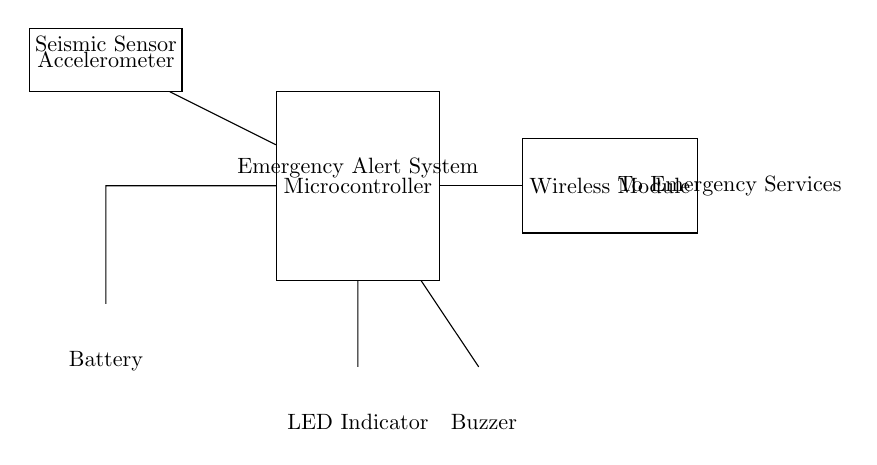What component detects seismic activity? The component that detects seismic activity in the circuit is the accelerometer. It is shown in the diagram labeled as "Seismic Sensor."
Answer: Accelerometer What is the function of the wireless module? The wireless module's function is to send alerts to emergency services. This is indicated by the label "To Emergency Services" next to the wireless module in the diagram.
Answer: Send alerts What are the two output indicators for the emergency alert system? The two output indicators are the LED Indicator and the Buzzer. These components are shown at the bottom of the circuit and are labeled accordingly.
Answer: LED Indicator and Buzzer How is the microcontroller powered? The microcontroller is powered by a battery. The circuit shows a connection from the battery, which is labeled as such, leading to the microcontroller.
Answer: Battery What is the role of the microcontroller in this circuit? The microcontroller's role in this circuit is to process data from the accelerometer and control the output devices (LED and Buzzer). It is labeled as "Emergency Alert System" in the diagram.
Answer: Process data How many main components are present in this circuit? There are five main components in the circuit: the microcontroller, accelerometer, wireless module, battery, and output devices (LED and Buzzer). Counting them in the diagram gives the total.
Answer: Five Which component indicates an emergency condition visually? The component that indicates an emergency condition visually is the LED Indicator. It is connected to the microcontroller and is labeled as such in the circuit diagram.
Answer: LED Indicator 